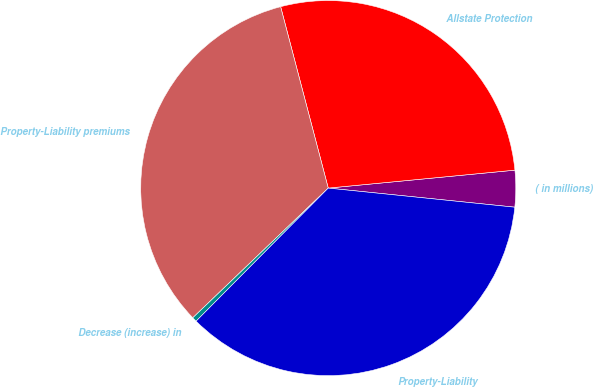Convert chart. <chart><loc_0><loc_0><loc_500><loc_500><pie_chart><fcel>( in millions)<fcel>Allstate Protection<fcel>Property-Liability premiums<fcel>Decrease (increase) in<fcel>Property-Liability<nl><fcel>3.15%<fcel>27.56%<fcel>33.07%<fcel>0.4%<fcel>35.82%<nl></chart> 